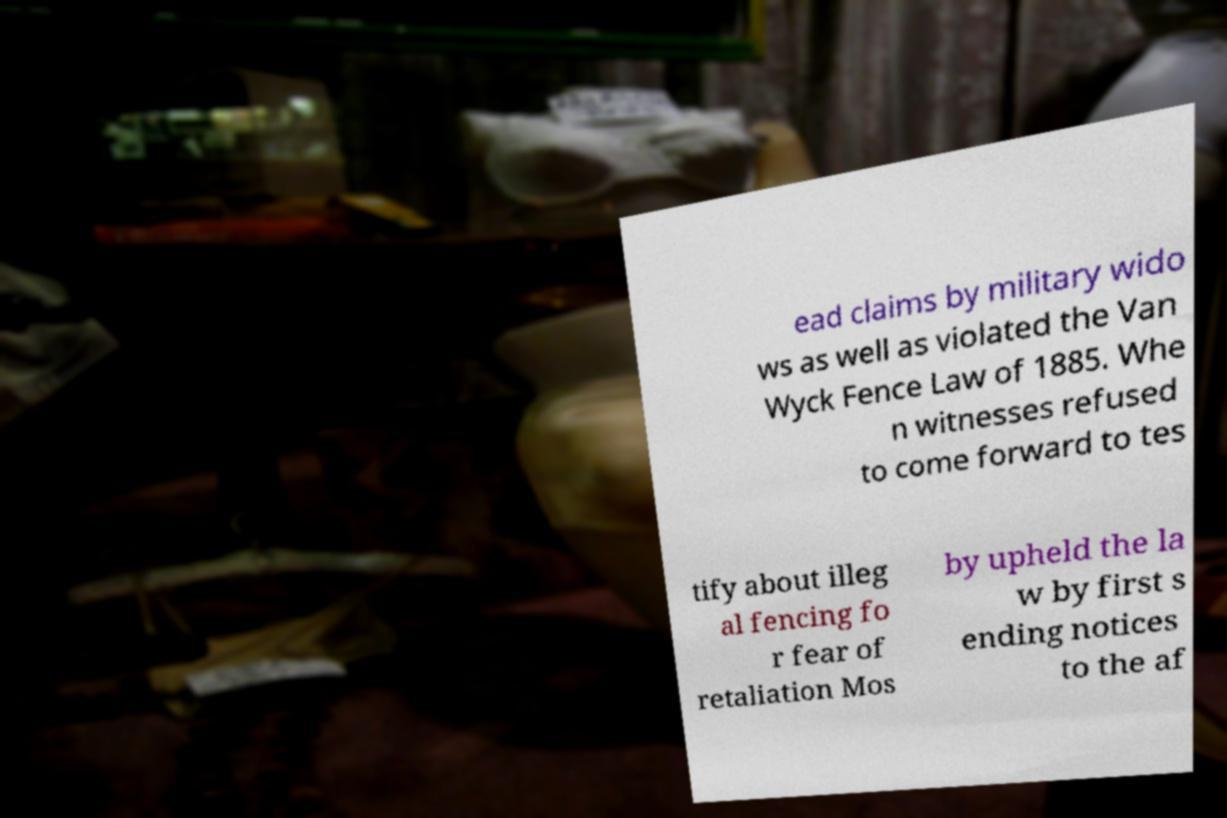Can you accurately transcribe the text from the provided image for me? ead claims by military wido ws as well as violated the Van Wyck Fence Law of 1885. Whe n witnesses refused to come forward to tes tify about illeg al fencing fo r fear of retaliation Mos by upheld the la w by first s ending notices to the af 